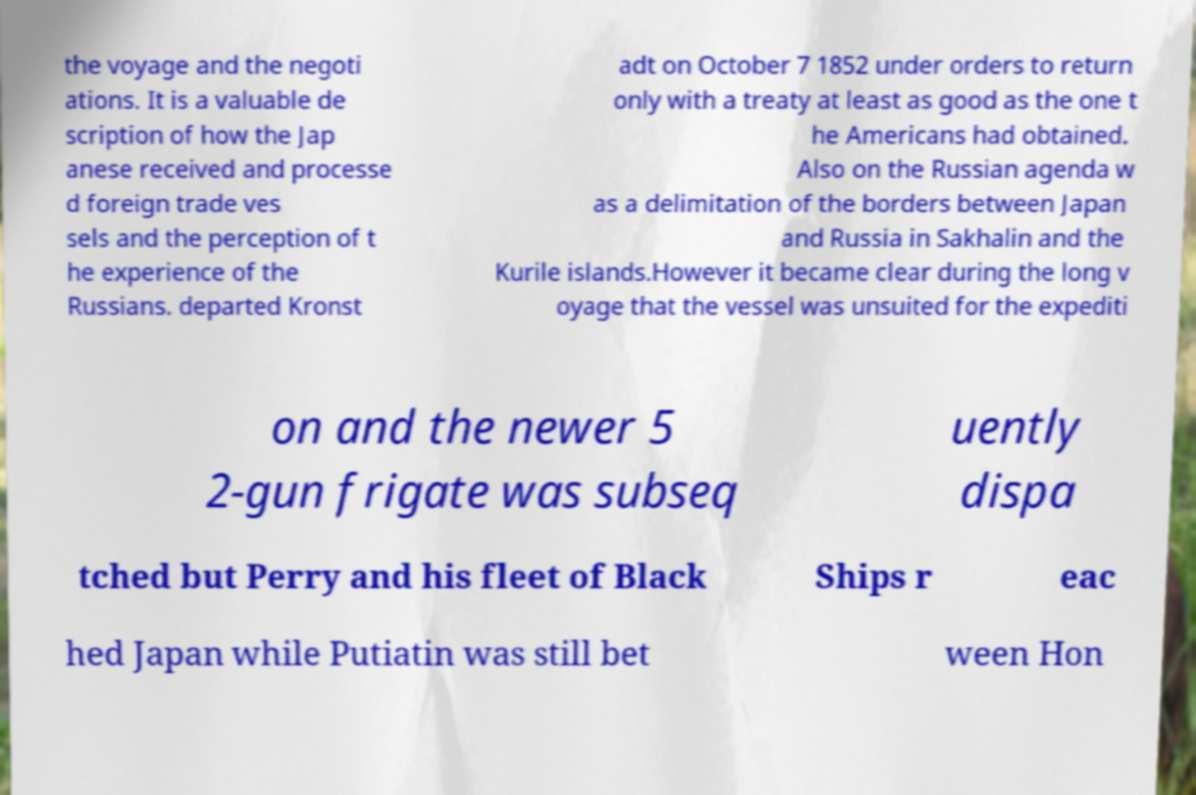What messages or text are displayed in this image? I need them in a readable, typed format. the voyage and the negoti ations. It is a valuable de scription of how the Jap anese received and processe d foreign trade ves sels and the perception of t he experience of the Russians. departed Kronst adt on October 7 1852 under orders to return only with a treaty at least as good as the one t he Americans had obtained. Also on the Russian agenda w as a delimitation of the borders between Japan and Russia in Sakhalin and the Kurile islands.However it became clear during the long v oyage that the vessel was unsuited for the expediti on and the newer 5 2-gun frigate was subseq uently dispa tched but Perry and his fleet of Black Ships r eac hed Japan while Putiatin was still bet ween Hon 